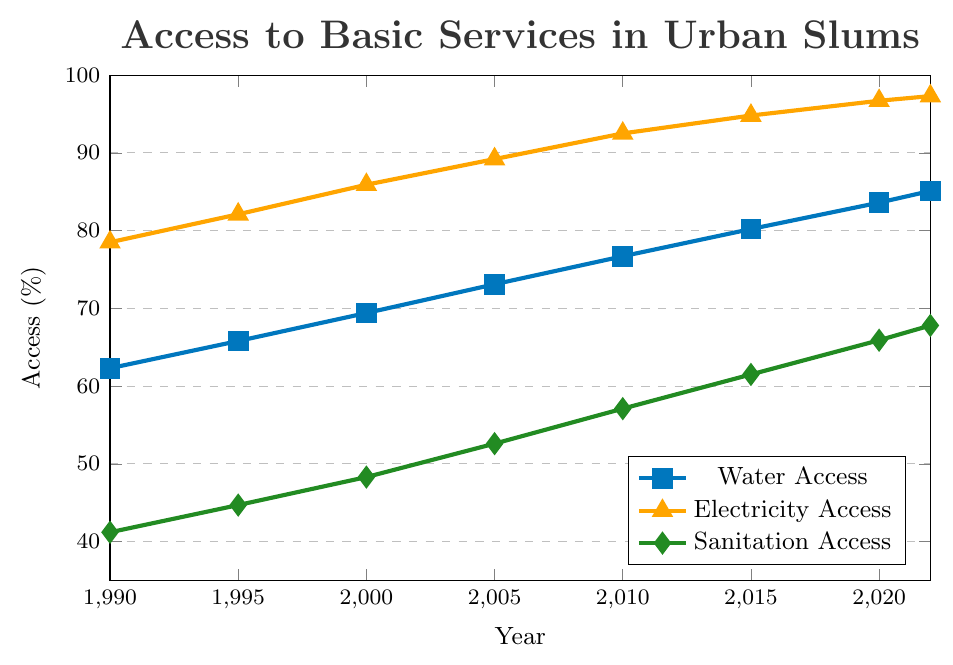What year did water access first exceed 80% in urban slums? According to the figure, water access first exceeded 80% in the year 2015.
Answer: 2015 Which type of service had the highest percentage access in 2005? In 2005, electricity access had the highest percentage at 89.2%.
Answer: Electricity By how much did sanitation access change from 1990 to 2022? Sanitation access increased from 41.2% in 1990 to 67.8% in 2022. The change is 67.8% - 41.2% = 26.6%.
Answer: 26.6% What is the difference between water and electricity access percentages in 2010? In 2010, water access was 76.7% and electricity access was 92.5%. The difference is 92.5% - 76.7% = 15.8%.
Answer: 15.8% Which year showed the smallest increase in sanitation access compared to the previous recorded year? Comparing the increments, from 2020 to 2022 sanitation access increased by 67.8% - 65.9% = 1.9%, which is the smallest increase.
Answer: 2022 On average, how much did water access increase per year from 1990 to 2022? From 1990 to 2022, water access increased from 62.3% to 85.1%. The total increase is 85.1% - 62.3% = 22.8%. There are 32 years between 1990 and 2022. The average annual increase is 22.8% / 32 years ≈ 0.71% per year.
Answer: 0.71% In which year did sanitation access surpass 50%? According to the figure, sanitation access surpassed 50% in the year 2005.
Answer: 2005 Comparing water access in 1990 and sanitation access in 2022, which is higher and by how much? Water access in 1990 was 62.3%, and sanitation access in 2022 was 67.8%. Sanitation access in 2022 is higher by 67.8% - 62.3% = 5.5%.
Answer: Sanitation access in 2022 by 5.5% How many years did it take for electricity access to reach 90%? Electricity access reached 90% between 2005 (89.2%) and 2010 (92.5%). Since it was below 90% in 2005 and above 90% by 2010, it took approximately 15 years from 1990 to 2005 to reach 90%.
Answer: 15 years 